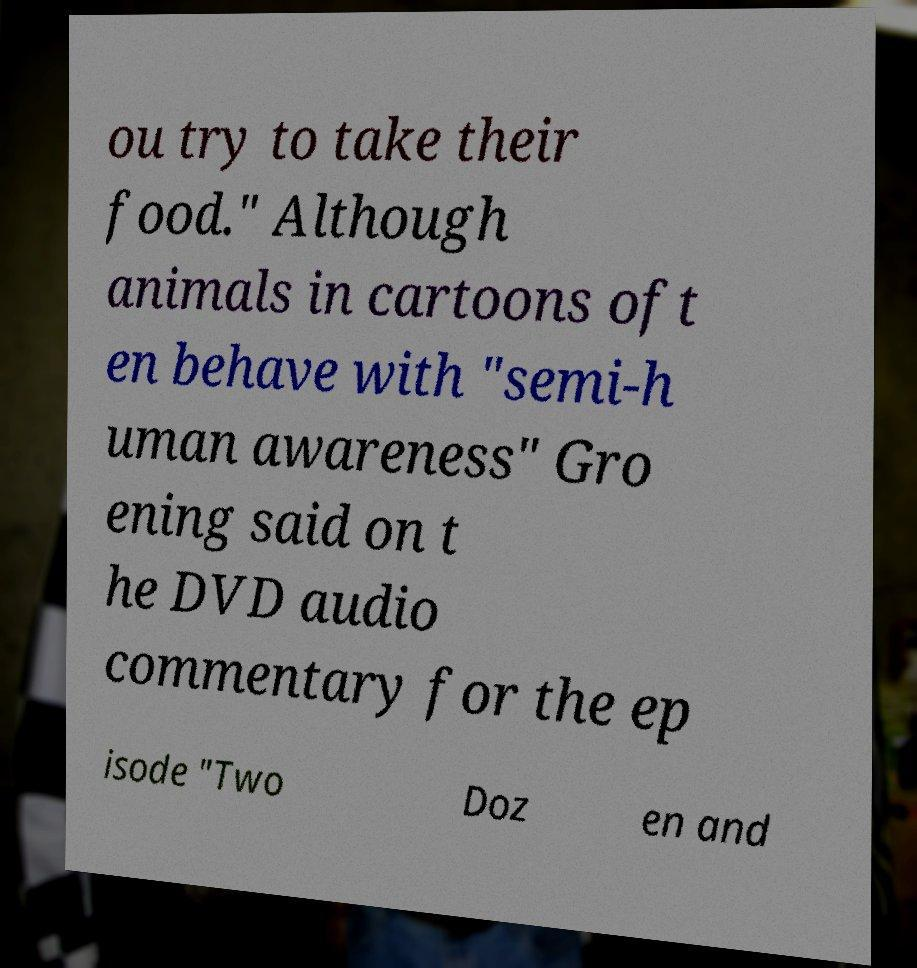Can you read and provide the text displayed in the image?This photo seems to have some interesting text. Can you extract and type it out for me? ou try to take their food." Although animals in cartoons oft en behave with "semi-h uman awareness" Gro ening said on t he DVD audio commentary for the ep isode "Two Doz en and 